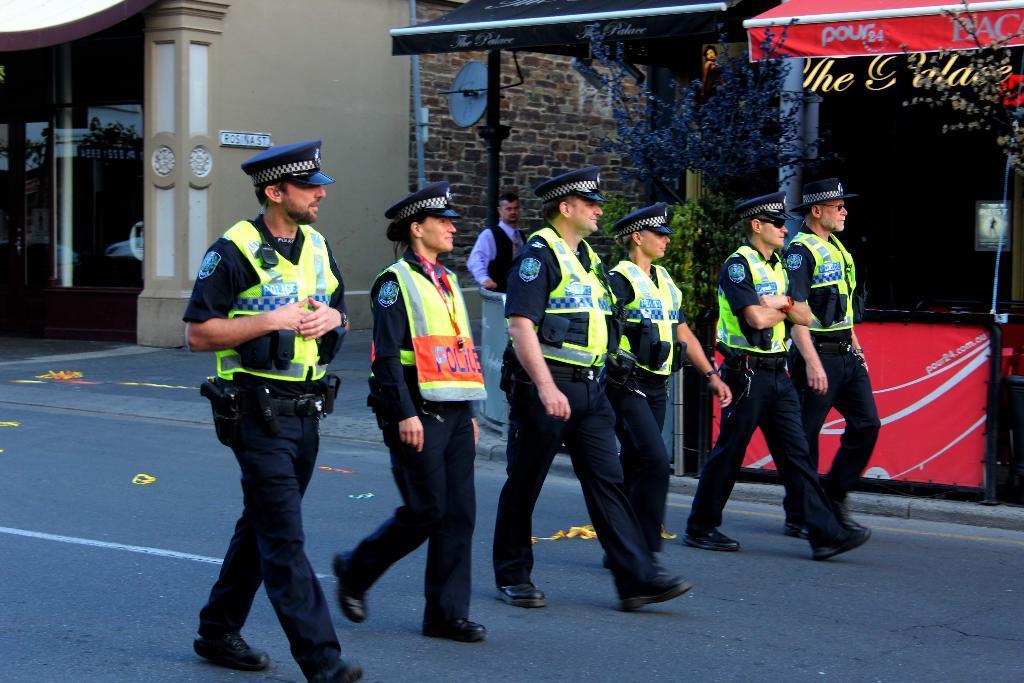Could you give a brief overview of what you see in this image? In this image we can see some police people walking on the road, some objects on the road, one building with glass door, one pipe attached to the wall, two shops, one nameplate attached to the wall, some trees, one man in the shop, some text on the shops, one dustbin, one poster with text and image attached to the shop glass window. 